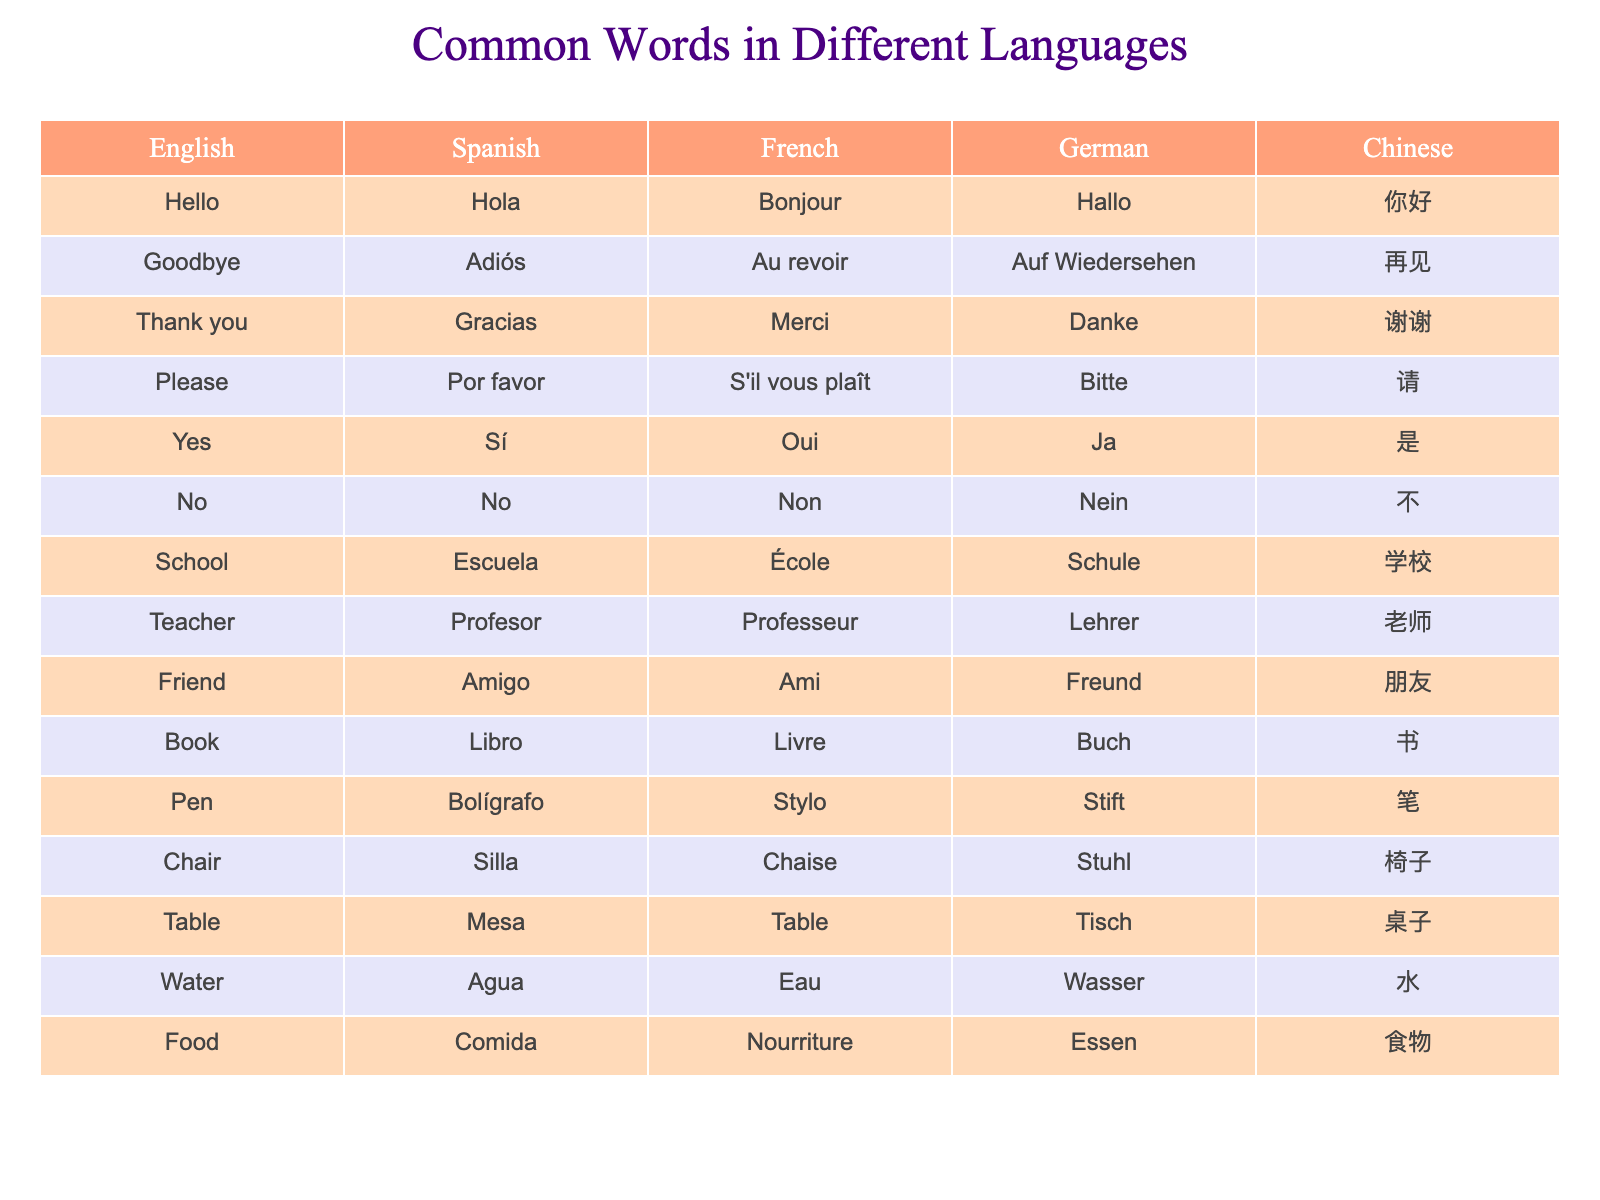What is the Spanish word for "Water"? In the table, the English word "Water" corresponds to the Spanish word "Agua" in the same row.
Answer: Agua What is the French translation of "Goodbye"? The table shows that the English word "Goodbye" translates to "Au revoir" in French.
Answer: Au revoir Is "Chair" the same in German and English? The English word "Chair" is "Stuhl" in German according to the table, so they are not the same.
Answer: No Which word in German means "Friend"? Looking at the table, the English word "Friend" translates to "Freund" in German.
Answer: Freund What is the Chinese translation of "Thank you"? The table indicates the English phrase "Thank you" translates to "谢谢" in Chinese.
Answer: 谢谢 Count how many words are listed in the table? There are 14 rows in the table, each representing a different word.
Answer: 14 Do the English words "Book" and "Pen" have the same meaning in Spanish? The English "Book" is translated to "Libro" and "Pen" to "Bolígrafo" in Spanish, which are different items, confirming they do not have the same meaning.
Answer: No If you combine "Please" and "Thank you," which language uses "Por favor" and "Gracias"? In Spanish, "Please" is "Por favor" and "Thank you" is "Gracias," so both phrases are used in Spanish.
Answer: Spanish What is the translation for "School" in French? The table shows that the English word "School" is translated as "École" in French.
Answer: École Is the word for "Yes" the same in Spanish and German? The English word "Yes" translates to "Sí" in Spanish and "Ja" in German, so they are different.
Answer: No If you list all the words in French, how many start with the letter "B"? In the table, "Bonjour," "Book," and "Bon" all start with "B." Thus, there are 3 words in French that begin with "B."
Answer: 3 